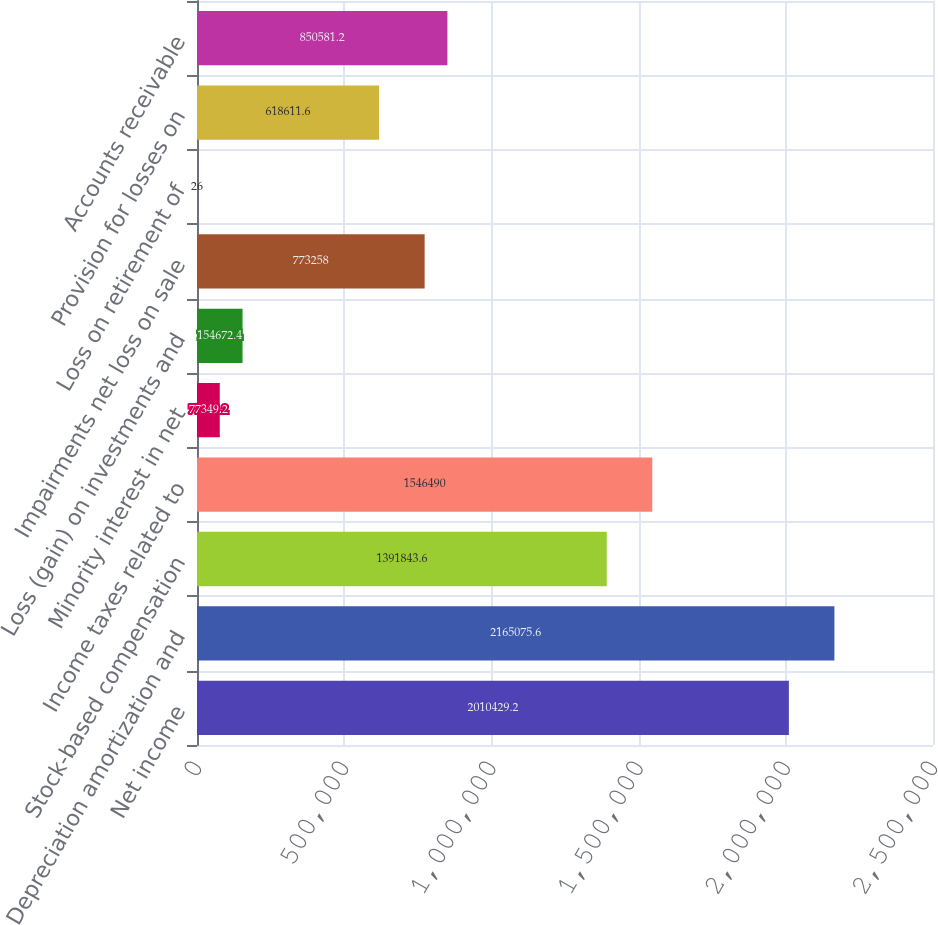<chart> <loc_0><loc_0><loc_500><loc_500><bar_chart><fcel>Net income<fcel>Depreciation amortization and<fcel>Stock-based compensation<fcel>Income taxes related to<fcel>Minority interest in net<fcel>Loss (gain) on investments and<fcel>Impairments net loss on sale<fcel>Loss on retirement of<fcel>Provision for losses on<fcel>Accounts receivable<nl><fcel>2.01043e+06<fcel>2.16508e+06<fcel>1.39184e+06<fcel>1.54649e+06<fcel>77349.2<fcel>154672<fcel>773258<fcel>26<fcel>618612<fcel>850581<nl></chart> 